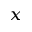<formula> <loc_0><loc_0><loc_500><loc_500>_ { x }</formula> 